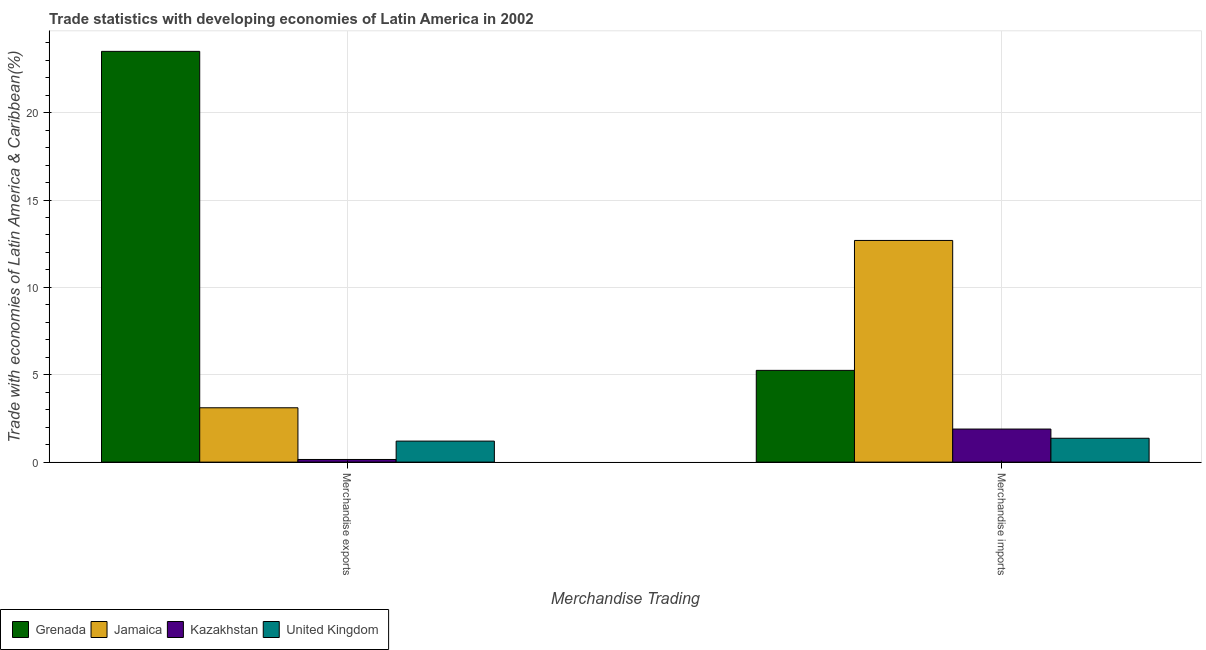Are the number of bars per tick equal to the number of legend labels?
Your answer should be very brief. Yes. How many bars are there on the 1st tick from the left?
Provide a succinct answer. 4. What is the label of the 1st group of bars from the left?
Your answer should be very brief. Merchandise exports. What is the merchandise imports in Jamaica?
Your response must be concise. 12.69. Across all countries, what is the maximum merchandise exports?
Your response must be concise. 23.51. Across all countries, what is the minimum merchandise imports?
Provide a short and direct response. 1.37. In which country was the merchandise imports maximum?
Provide a succinct answer. Jamaica. In which country was the merchandise exports minimum?
Your answer should be very brief. Kazakhstan. What is the total merchandise imports in the graph?
Give a very brief answer. 21.2. What is the difference between the merchandise imports in Kazakhstan and that in United Kingdom?
Your answer should be very brief. 0.53. What is the difference between the merchandise imports in Kazakhstan and the merchandise exports in United Kingdom?
Ensure brevity in your answer.  0.69. What is the average merchandise exports per country?
Offer a very short reply. 6.99. What is the difference between the merchandise imports and merchandise exports in Grenada?
Make the answer very short. -18.26. In how many countries, is the merchandise imports greater than 23 %?
Your answer should be very brief. 0. What is the ratio of the merchandise imports in Kazakhstan to that in Jamaica?
Your answer should be very brief. 0.15. Is the merchandise imports in Grenada less than that in Jamaica?
Offer a terse response. Yes. In how many countries, is the merchandise exports greater than the average merchandise exports taken over all countries?
Ensure brevity in your answer.  1. What does the 3rd bar from the left in Merchandise imports represents?
Keep it short and to the point. Kazakhstan. What does the 3rd bar from the right in Merchandise exports represents?
Ensure brevity in your answer.  Jamaica. Are all the bars in the graph horizontal?
Offer a terse response. No. How many countries are there in the graph?
Offer a terse response. 4. Are the values on the major ticks of Y-axis written in scientific E-notation?
Keep it short and to the point. No. Does the graph contain any zero values?
Provide a short and direct response. No. Does the graph contain grids?
Make the answer very short. Yes. Where does the legend appear in the graph?
Provide a succinct answer. Bottom left. How many legend labels are there?
Offer a very short reply. 4. What is the title of the graph?
Your response must be concise. Trade statistics with developing economies of Latin America in 2002. What is the label or title of the X-axis?
Provide a succinct answer. Merchandise Trading. What is the label or title of the Y-axis?
Ensure brevity in your answer.  Trade with economies of Latin America & Caribbean(%). What is the Trade with economies of Latin America & Caribbean(%) of Grenada in Merchandise exports?
Ensure brevity in your answer.  23.51. What is the Trade with economies of Latin America & Caribbean(%) in Jamaica in Merchandise exports?
Provide a succinct answer. 3.11. What is the Trade with economies of Latin America & Caribbean(%) of Kazakhstan in Merchandise exports?
Ensure brevity in your answer.  0.15. What is the Trade with economies of Latin America & Caribbean(%) in United Kingdom in Merchandise exports?
Your response must be concise. 1.2. What is the Trade with economies of Latin America & Caribbean(%) of Grenada in Merchandise imports?
Your answer should be compact. 5.25. What is the Trade with economies of Latin America & Caribbean(%) of Jamaica in Merchandise imports?
Make the answer very short. 12.69. What is the Trade with economies of Latin America & Caribbean(%) of Kazakhstan in Merchandise imports?
Offer a terse response. 1.89. What is the Trade with economies of Latin America & Caribbean(%) in United Kingdom in Merchandise imports?
Provide a short and direct response. 1.37. Across all Merchandise Trading, what is the maximum Trade with economies of Latin America & Caribbean(%) in Grenada?
Give a very brief answer. 23.51. Across all Merchandise Trading, what is the maximum Trade with economies of Latin America & Caribbean(%) in Jamaica?
Make the answer very short. 12.69. Across all Merchandise Trading, what is the maximum Trade with economies of Latin America & Caribbean(%) in Kazakhstan?
Keep it short and to the point. 1.89. Across all Merchandise Trading, what is the maximum Trade with economies of Latin America & Caribbean(%) in United Kingdom?
Keep it short and to the point. 1.37. Across all Merchandise Trading, what is the minimum Trade with economies of Latin America & Caribbean(%) in Grenada?
Make the answer very short. 5.25. Across all Merchandise Trading, what is the minimum Trade with economies of Latin America & Caribbean(%) in Jamaica?
Your answer should be very brief. 3.11. Across all Merchandise Trading, what is the minimum Trade with economies of Latin America & Caribbean(%) in Kazakhstan?
Your response must be concise. 0.15. Across all Merchandise Trading, what is the minimum Trade with economies of Latin America & Caribbean(%) in United Kingdom?
Provide a succinct answer. 1.2. What is the total Trade with economies of Latin America & Caribbean(%) of Grenada in the graph?
Keep it short and to the point. 28.76. What is the total Trade with economies of Latin America & Caribbean(%) in Jamaica in the graph?
Make the answer very short. 15.8. What is the total Trade with economies of Latin America & Caribbean(%) in Kazakhstan in the graph?
Provide a succinct answer. 2.04. What is the total Trade with economies of Latin America & Caribbean(%) in United Kingdom in the graph?
Ensure brevity in your answer.  2.57. What is the difference between the Trade with economies of Latin America & Caribbean(%) of Grenada in Merchandise exports and that in Merchandise imports?
Keep it short and to the point. 18.26. What is the difference between the Trade with economies of Latin America & Caribbean(%) of Jamaica in Merchandise exports and that in Merchandise imports?
Give a very brief answer. -9.58. What is the difference between the Trade with economies of Latin America & Caribbean(%) in Kazakhstan in Merchandise exports and that in Merchandise imports?
Keep it short and to the point. -1.74. What is the difference between the Trade with economies of Latin America & Caribbean(%) of United Kingdom in Merchandise exports and that in Merchandise imports?
Offer a very short reply. -0.16. What is the difference between the Trade with economies of Latin America & Caribbean(%) of Grenada in Merchandise exports and the Trade with economies of Latin America & Caribbean(%) of Jamaica in Merchandise imports?
Keep it short and to the point. 10.82. What is the difference between the Trade with economies of Latin America & Caribbean(%) of Grenada in Merchandise exports and the Trade with economies of Latin America & Caribbean(%) of Kazakhstan in Merchandise imports?
Keep it short and to the point. 21.62. What is the difference between the Trade with economies of Latin America & Caribbean(%) in Grenada in Merchandise exports and the Trade with economies of Latin America & Caribbean(%) in United Kingdom in Merchandise imports?
Ensure brevity in your answer.  22.14. What is the difference between the Trade with economies of Latin America & Caribbean(%) of Jamaica in Merchandise exports and the Trade with economies of Latin America & Caribbean(%) of Kazakhstan in Merchandise imports?
Your answer should be compact. 1.22. What is the difference between the Trade with economies of Latin America & Caribbean(%) of Jamaica in Merchandise exports and the Trade with economies of Latin America & Caribbean(%) of United Kingdom in Merchandise imports?
Offer a very short reply. 1.75. What is the difference between the Trade with economies of Latin America & Caribbean(%) of Kazakhstan in Merchandise exports and the Trade with economies of Latin America & Caribbean(%) of United Kingdom in Merchandise imports?
Your answer should be very brief. -1.21. What is the average Trade with economies of Latin America & Caribbean(%) of Grenada per Merchandise Trading?
Give a very brief answer. 14.38. What is the average Trade with economies of Latin America & Caribbean(%) of Jamaica per Merchandise Trading?
Provide a succinct answer. 7.9. What is the average Trade with economies of Latin America & Caribbean(%) in Kazakhstan per Merchandise Trading?
Offer a very short reply. 1.02. What is the average Trade with economies of Latin America & Caribbean(%) of United Kingdom per Merchandise Trading?
Make the answer very short. 1.28. What is the difference between the Trade with economies of Latin America & Caribbean(%) in Grenada and Trade with economies of Latin America & Caribbean(%) in Jamaica in Merchandise exports?
Keep it short and to the point. 20.4. What is the difference between the Trade with economies of Latin America & Caribbean(%) of Grenada and Trade with economies of Latin America & Caribbean(%) of Kazakhstan in Merchandise exports?
Your answer should be very brief. 23.36. What is the difference between the Trade with economies of Latin America & Caribbean(%) of Grenada and Trade with economies of Latin America & Caribbean(%) of United Kingdom in Merchandise exports?
Provide a short and direct response. 22.31. What is the difference between the Trade with economies of Latin America & Caribbean(%) of Jamaica and Trade with economies of Latin America & Caribbean(%) of Kazakhstan in Merchandise exports?
Offer a very short reply. 2.96. What is the difference between the Trade with economies of Latin America & Caribbean(%) in Jamaica and Trade with economies of Latin America & Caribbean(%) in United Kingdom in Merchandise exports?
Provide a succinct answer. 1.91. What is the difference between the Trade with economies of Latin America & Caribbean(%) of Kazakhstan and Trade with economies of Latin America & Caribbean(%) of United Kingdom in Merchandise exports?
Your response must be concise. -1.05. What is the difference between the Trade with economies of Latin America & Caribbean(%) in Grenada and Trade with economies of Latin America & Caribbean(%) in Jamaica in Merchandise imports?
Your answer should be compact. -7.44. What is the difference between the Trade with economies of Latin America & Caribbean(%) of Grenada and Trade with economies of Latin America & Caribbean(%) of Kazakhstan in Merchandise imports?
Your answer should be very brief. 3.36. What is the difference between the Trade with economies of Latin America & Caribbean(%) in Grenada and Trade with economies of Latin America & Caribbean(%) in United Kingdom in Merchandise imports?
Offer a terse response. 3.89. What is the difference between the Trade with economies of Latin America & Caribbean(%) in Jamaica and Trade with economies of Latin America & Caribbean(%) in Kazakhstan in Merchandise imports?
Offer a very short reply. 10.79. What is the difference between the Trade with economies of Latin America & Caribbean(%) in Jamaica and Trade with economies of Latin America & Caribbean(%) in United Kingdom in Merchandise imports?
Offer a terse response. 11.32. What is the difference between the Trade with economies of Latin America & Caribbean(%) of Kazakhstan and Trade with economies of Latin America & Caribbean(%) of United Kingdom in Merchandise imports?
Your response must be concise. 0.53. What is the ratio of the Trade with economies of Latin America & Caribbean(%) of Grenada in Merchandise exports to that in Merchandise imports?
Make the answer very short. 4.48. What is the ratio of the Trade with economies of Latin America & Caribbean(%) in Jamaica in Merchandise exports to that in Merchandise imports?
Give a very brief answer. 0.25. What is the ratio of the Trade with economies of Latin America & Caribbean(%) of Kazakhstan in Merchandise exports to that in Merchandise imports?
Ensure brevity in your answer.  0.08. What is the ratio of the Trade with economies of Latin America & Caribbean(%) in United Kingdom in Merchandise exports to that in Merchandise imports?
Offer a terse response. 0.88. What is the difference between the highest and the second highest Trade with economies of Latin America & Caribbean(%) of Grenada?
Keep it short and to the point. 18.26. What is the difference between the highest and the second highest Trade with economies of Latin America & Caribbean(%) in Jamaica?
Provide a short and direct response. 9.58. What is the difference between the highest and the second highest Trade with economies of Latin America & Caribbean(%) of Kazakhstan?
Your answer should be compact. 1.74. What is the difference between the highest and the second highest Trade with economies of Latin America & Caribbean(%) in United Kingdom?
Your answer should be compact. 0.16. What is the difference between the highest and the lowest Trade with economies of Latin America & Caribbean(%) of Grenada?
Ensure brevity in your answer.  18.26. What is the difference between the highest and the lowest Trade with economies of Latin America & Caribbean(%) in Jamaica?
Keep it short and to the point. 9.58. What is the difference between the highest and the lowest Trade with economies of Latin America & Caribbean(%) in Kazakhstan?
Provide a short and direct response. 1.74. What is the difference between the highest and the lowest Trade with economies of Latin America & Caribbean(%) of United Kingdom?
Make the answer very short. 0.16. 